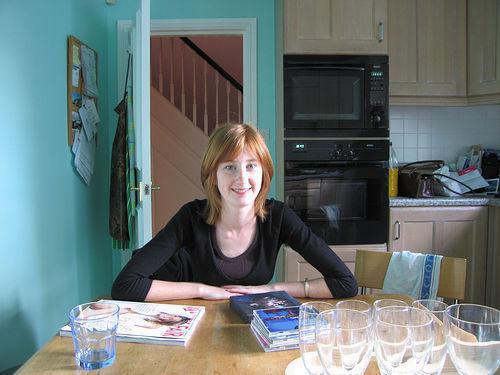How many people are drinking water?
Give a very brief answer. 0. 